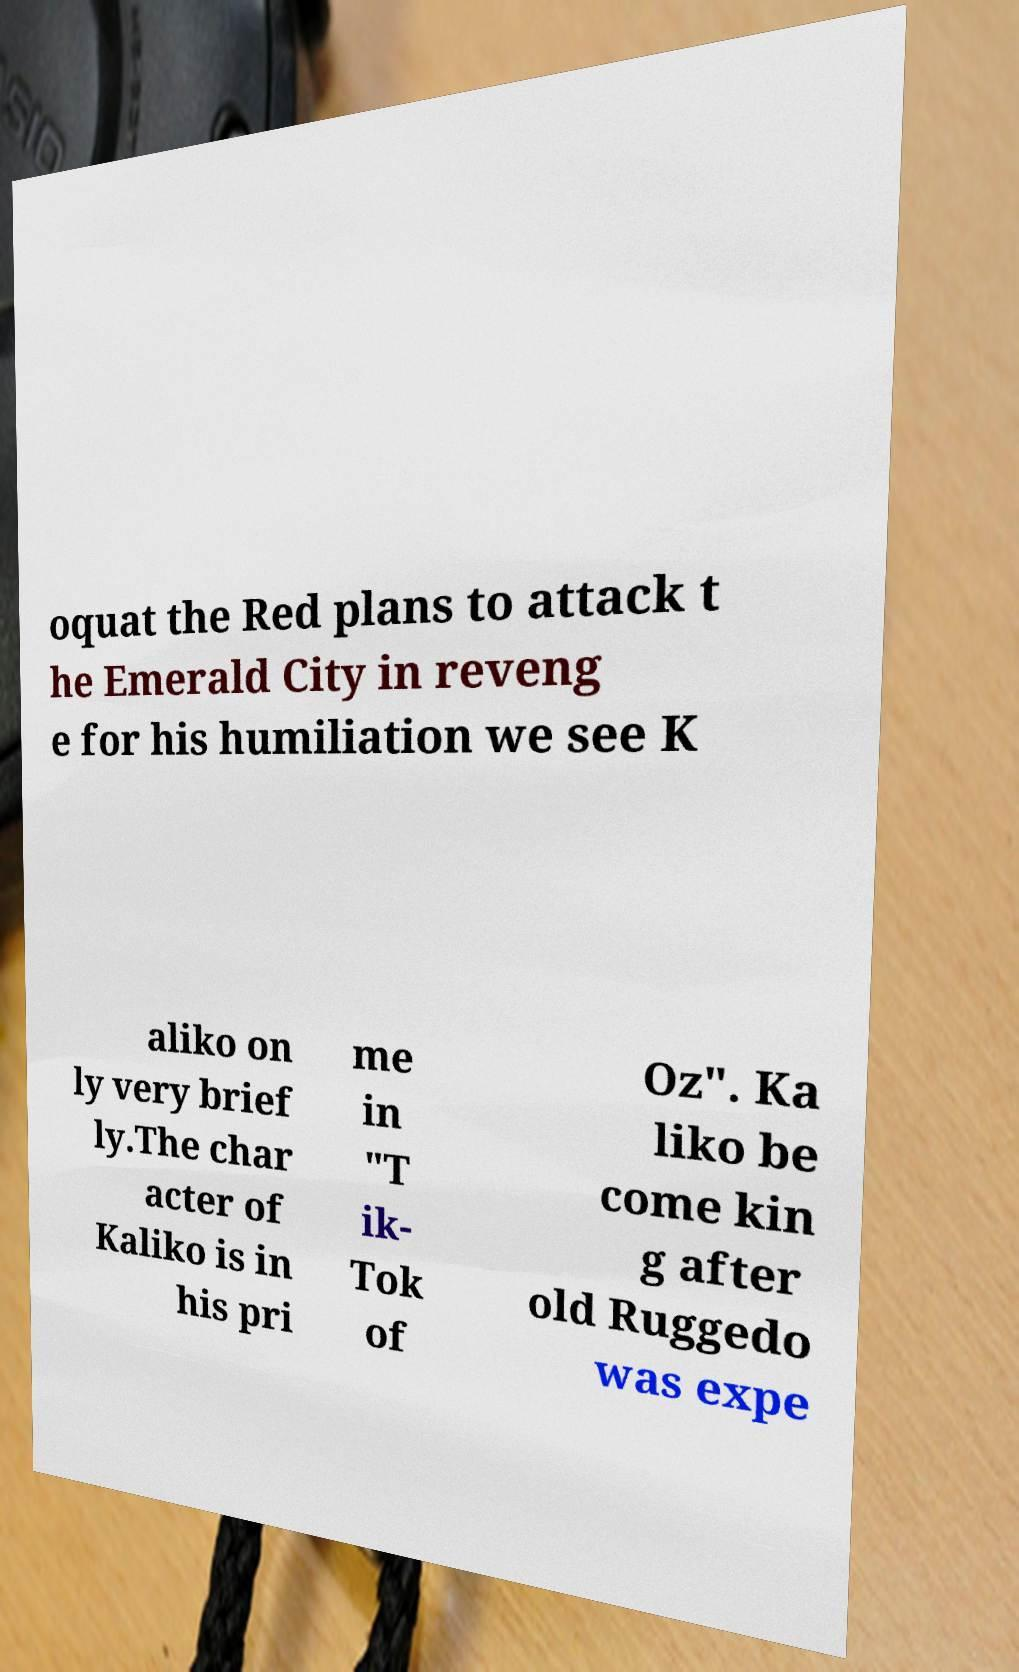For documentation purposes, I need the text within this image transcribed. Could you provide that? oquat the Red plans to attack t he Emerald City in reveng e for his humiliation we see K aliko on ly very brief ly.The char acter of Kaliko is in his pri me in "T ik- Tok of Oz". Ka liko be come kin g after old Ruggedo was expe 